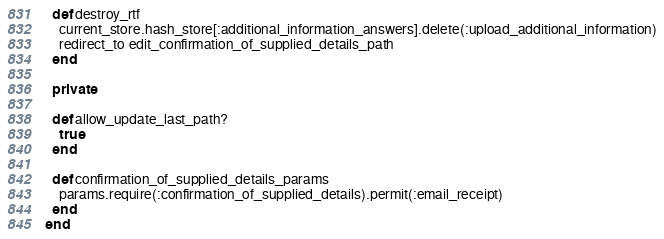<code> <loc_0><loc_0><loc_500><loc_500><_Ruby_>  def destroy_rtf
    current_store.hash_store[:additional_information_answers].delete(:upload_additional_information)
    redirect_to edit_confirmation_of_supplied_details_path
  end

  private

  def allow_update_last_path?
    true
  end

  def confirmation_of_supplied_details_params
    params.require(:confirmation_of_supplied_details).permit(:email_receipt)
  end
end
</code> 